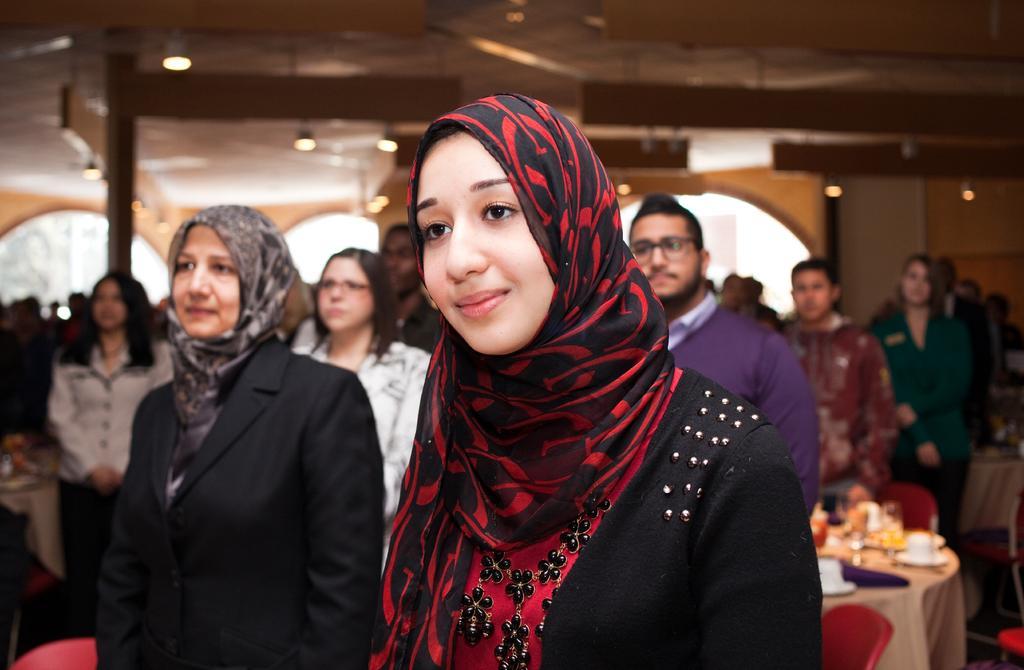In one or two sentences, can you explain what this image depicts? In this picture we can see a group of people, here we can see tables, glasses and some objects and in the background we can see lights, roof and some objects. 